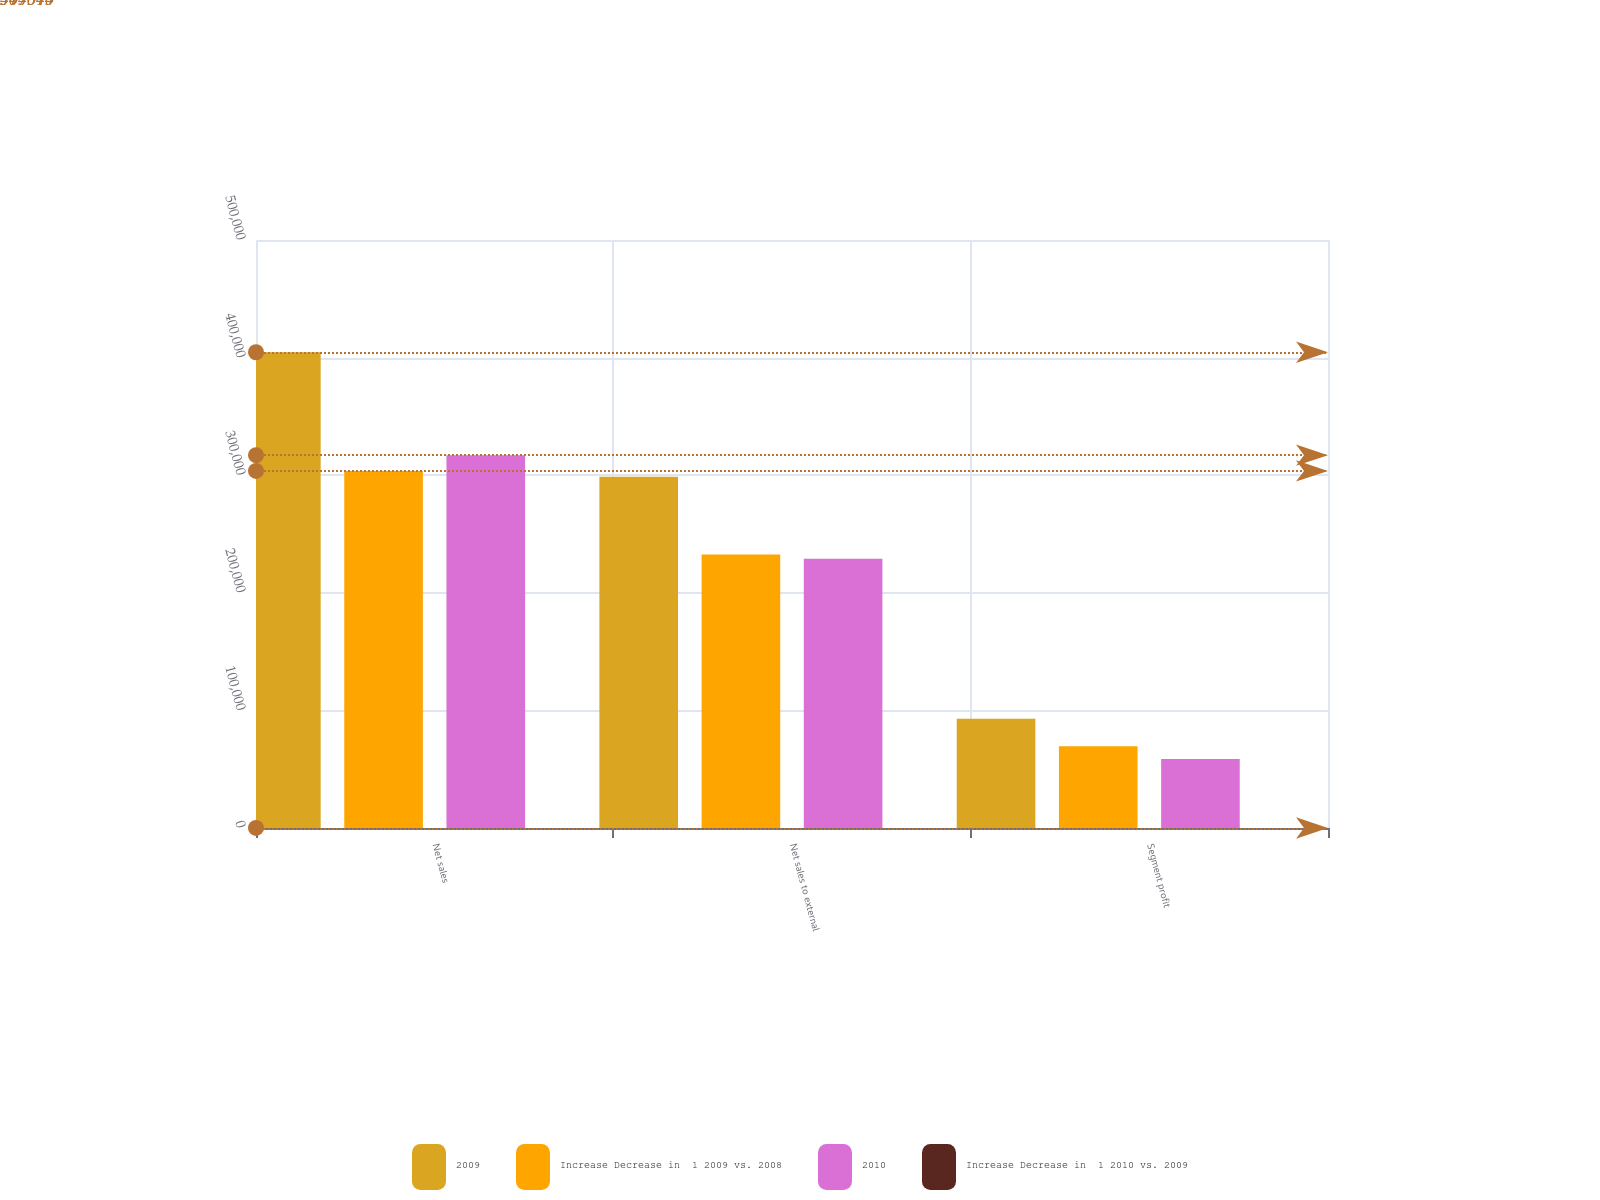<chart> <loc_0><loc_0><loc_500><loc_500><stacked_bar_chart><ecel><fcel>Net sales<fcel>Net sales to external<fcel>Segment profit<nl><fcel>2009<fcel>404543<fcel>298637<fcel>92969<nl><fcel>Increase Decrease in  1 2009 vs. 2008<fcel>303614<fcel>232643<fcel>69617<nl><fcel>2010<fcel>317040<fcel>228890<fcel>58779<nl><fcel>Increase Decrease in  1 2010 vs. 2009<fcel>33<fcel>28<fcel>34<nl></chart> 